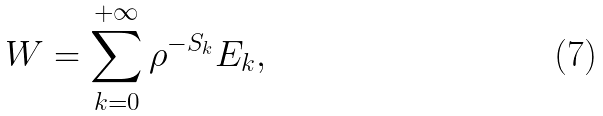Convert formula to latex. <formula><loc_0><loc_0><loc_500><loc_500>W = \sum _ { k = 0 } ^ { + \infty } \rho ^ { - S _ { k } } E _ { k } ,</formula> 